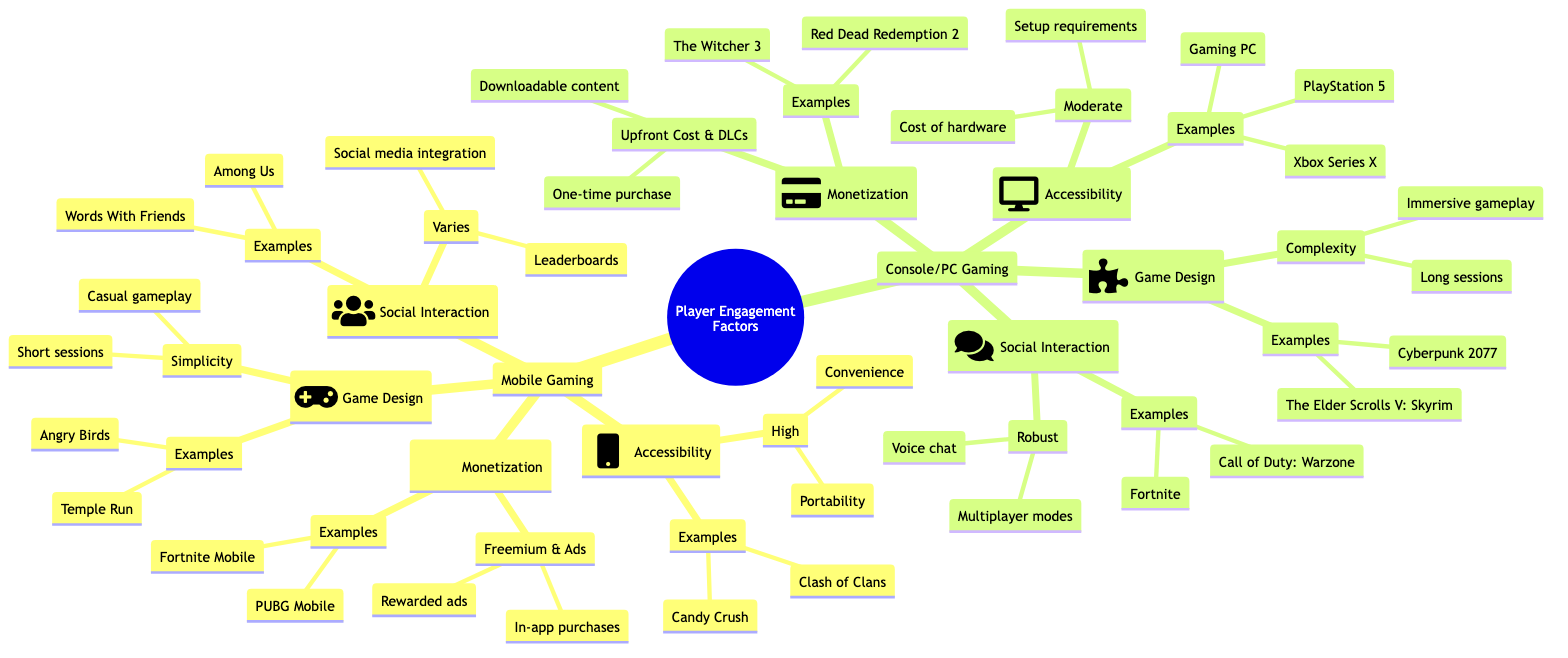What is the main aspect of mobile game design? The diagram indicates that the main aspect of mobile game design is "Simplicity." This can be found under the "Game Design" node in the "Mobile Gaming" section.
Answer: Simplicity What are the monetization mechanisms for console/PC gaming? Upon examining the "Monetization" section under "Console/PC Gaming," the mechanisms listed are "One-time purchase" and "Downloadable content." These are essential formats for monetizing games on these platforms.
Answer: One-time purchase, Downloadable content Which mobile game example is listed under social interaction? The social interaction section in "Mobile Gaming" mentions "Words With Friends" as one of the examples provided. This connects to the aspect of social interaction which varies based on the game's design.
Answer: Words With Friends What type of gameplay is emphasized in console/PC gaming? The "Game Design" section under "Console/PC Gaming" highlights "Complexity" as the aspect of gameplay, which emphasizes immersive experiences and longer sessions. This suggests a more in-depth gameplay experience compared to mobile gaming.
Answer: Complexity How many examples of mobile games are provided in the game design section? In the "Game Design" section for "Mobile Gaming," there are two examples listed: "Angry Birds" and "Temple Run." This indicates the focus on simplicity in mobile game design with specific representations.
Answer: 2 What barriers to accessibility are mentioned for console/PC gaming? The "Accessibility" section under "Console/PC Gaming" cites "Cost of hardware" and "Setup requirements" as barriers. This information reveals the higher entry requirements compared to mobile gaming's accessibility.
Answer: Cost of hardware, Setup requirements What is the aspect of social interaction in mobile gaming? In the "Social Interaction" area for "Mobile Gaming," the aspect noted is "Varies." This implies that social interaction can differ widely depending on the specific game and its design features or integrations.
Answer: Varies What examples of monetization are noted in mobile gaming? The monetization section for "Mobile Gaming" provides examples such as "Fortnite Mobile" and "PUBG Mobile," showcasing how these games implement freemium and ad-based monetization strategies.
Answer: Fortnite Mobile, PUBG Mobile What are the characteristics of console/PC gaming design? Characteristics listed under the "Game Design" section for "Console/PC Gaming" include "Immersive gameplay" and "Long sessions," indicating a focus on depth and engagement that differs from mobile gaming experiences.
Answer: Immersive gameplay, Long sessions 